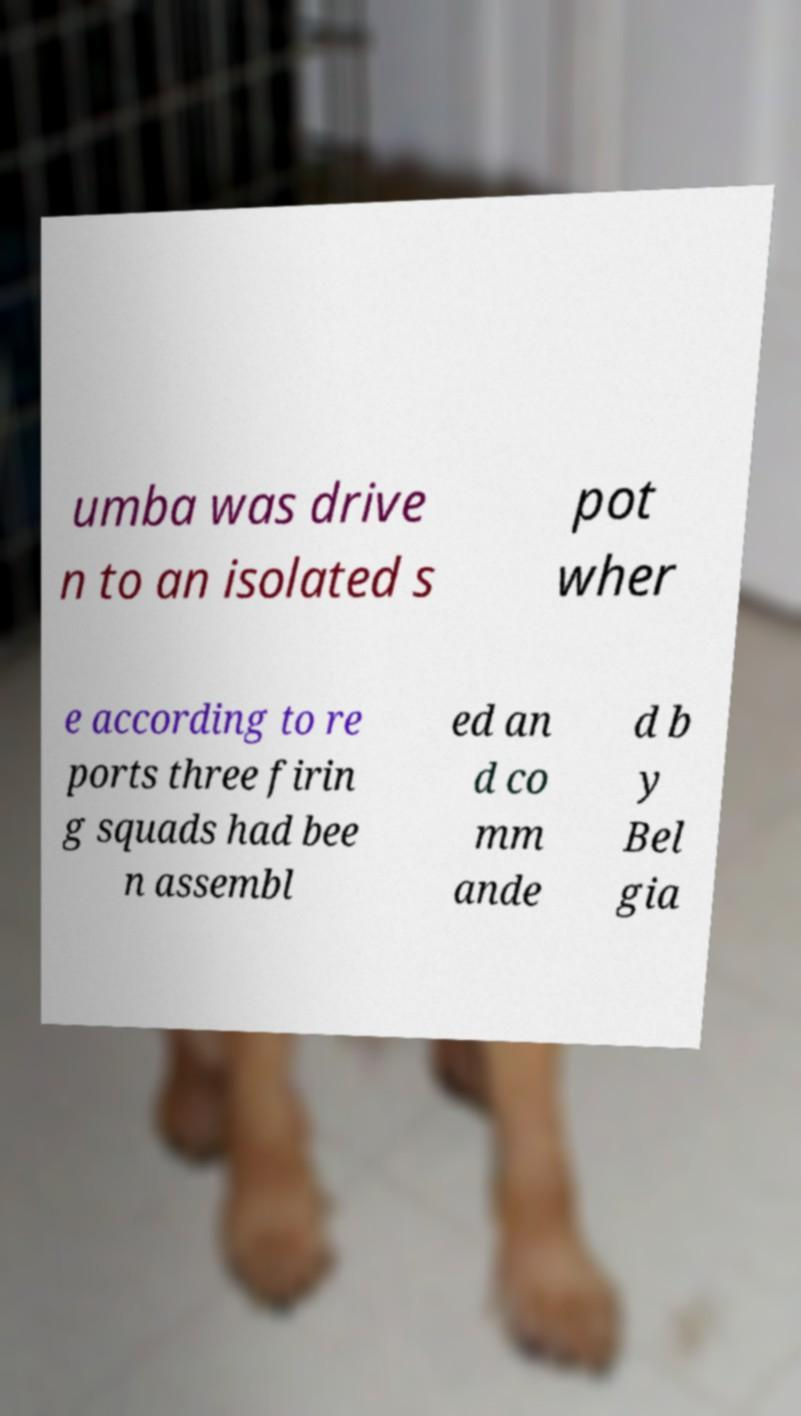There's text embedded in this image that I need extracted. Can you transcribe it verbatim? umba was drive n to an isolated s pot wher e according to re ports three firin g squads had bee n assembl ed an d co mm ande d b y Bel gia 